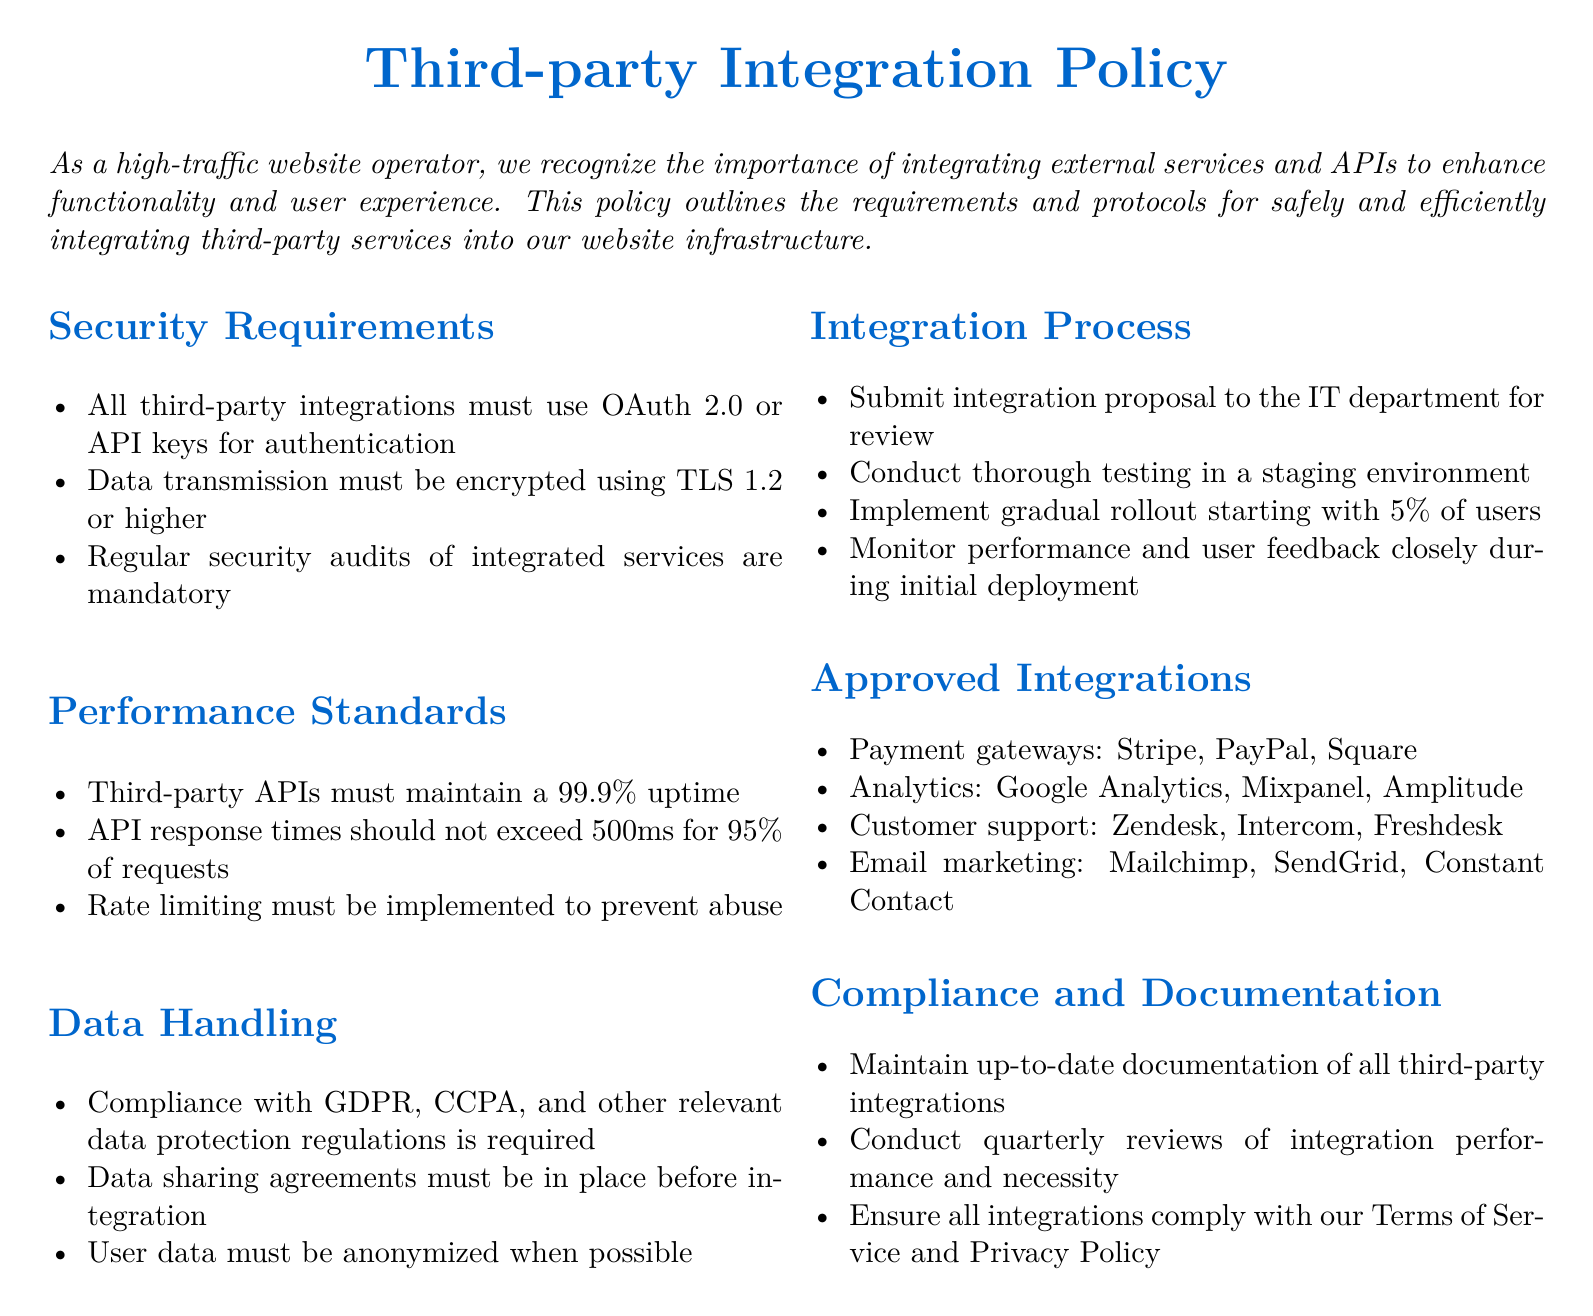What authentication methods are required for third-party integrations? The document specifies that all third-party integrations must use OAuth 2.0 or API keys for authentication.
Answer: OAuth 2.0 or API keys What encryption protocol must be used for data transmission? The policy states that data transmission must be encrypted using TLS 1.2 or higher.
Answer: TLS 1.2 or higher What is the required uptime for third-party APIs? The document indicates that third-party APIs must maintain a 99.9% uptime.
Answer: 99.9% How often must security audits of integrated services be conducted? According to the policy, regular security audits of integrated services are mandatory, though a specific frequency isn't given.
Answer: Regularly What is the maximum API response time allowed for 95% of requests? The document specifies that API response times should not exceed 500ms for 95% of requests.
Answer: 500ms What agreements must be in place before integrating third-party services? The policy requires that data sharing agreements must be in place before integration.
Answer: Data sharing agreements What is the first step in the integration process? The integration process starts with submitting an integration proposal to the IT department for review.
Answer: Submit integration proposal Which payment gateways are approved for integration? The policy lists the approved payment gateways as Stripe, PayPal, and Square.
Answer: Stripe, PayPal, Square How often must integration performance be reviewed? The document states that quarterly reviews of integration performance and necessity are required.
Answer: Quarterly What type of integration must user data comply with? The document mandates compliance with GDPR, CCPA, and other relevant data protection regulations for user data.
Answer: GDPR, CCPA 